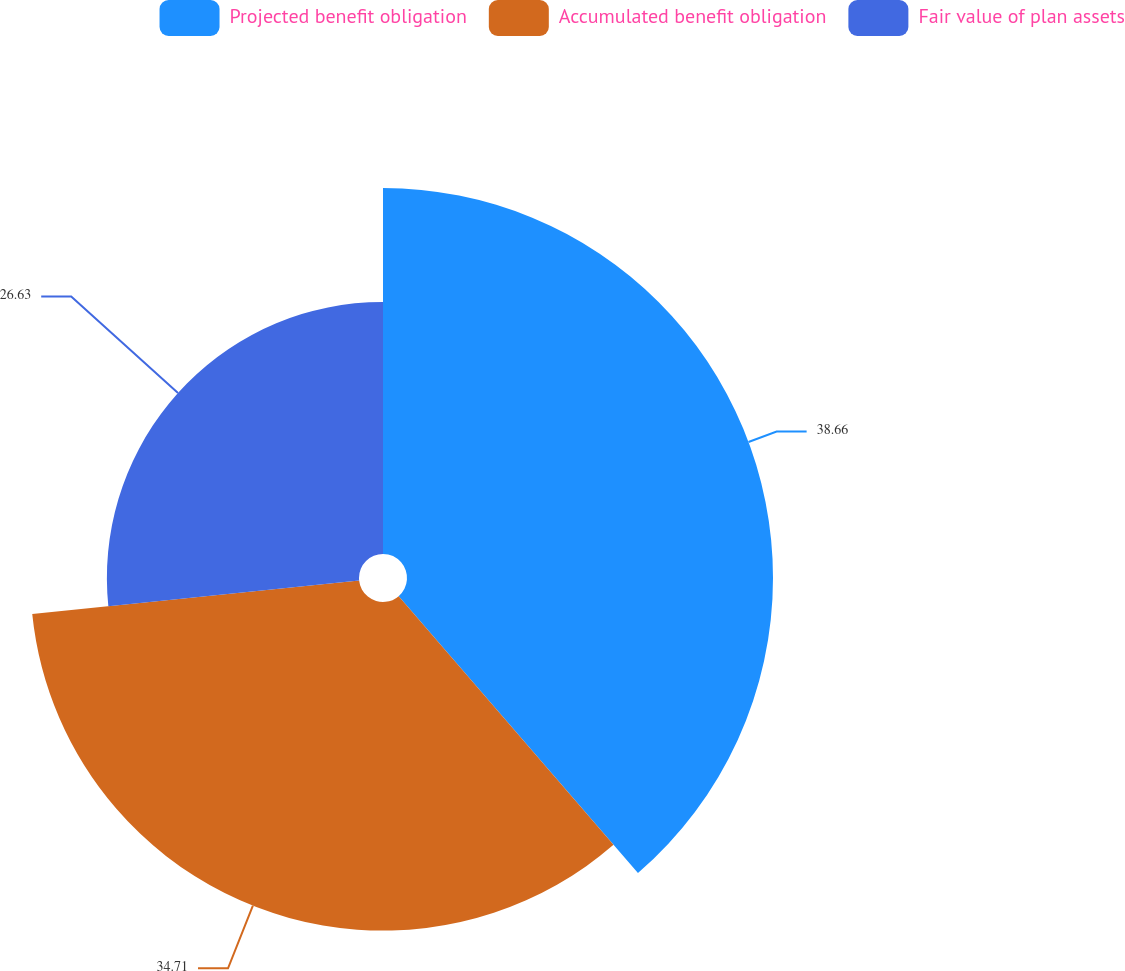<chart> <loc_0><loc_0><loc_500><loc_500><pie_chart><fcel>Projected benefit obligation<fcel>Accumulated benefit obligation<fcel>Fair value of plan assets<nl><fcel>38.66%<fcel>34.71%<fcel>26.63%<nl></chart> 